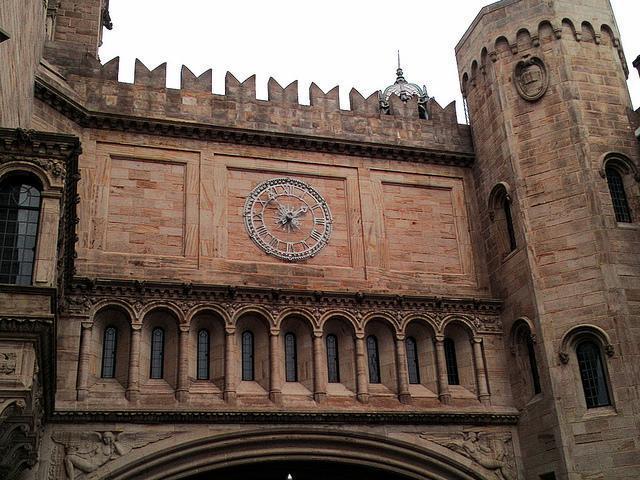How many panels on either side of the clock?
Give a very brief answer. 2. How many archways are visible?
Give a very brief answer. 1. How many clocks are visible?
Give a very brief answer. 1. How many people are there?
Give a very brief answer. 0. 